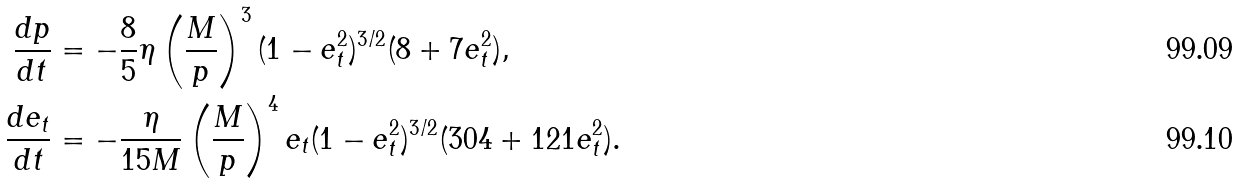<formula> <loc_0><loc_0><loc_500><loc_500>\frac { d p } { d t } & = - \frac { 8 } { 5 } \eta \left ( \frac { M } { p } \right ) ^ { 3 } ( 1 - e _ { t } ^ { 2 } ) ^ { 3 / 2 } ( 8 + 7 e _ { t } ^ { 2 } ) , \\ \frac { d e _ { t } } { d t } & = - \frac { \eta } { 1 5 M } \left ( \frac { M } { p } \right ) ^ { 4 } e _ { t } ( 1 - e _ { t } ^ { 2 } ) ^ { 3 / 2 } ( 3 0 4 + 1 2 1 e _ { t } ^ { 2 } ) .</formula> 